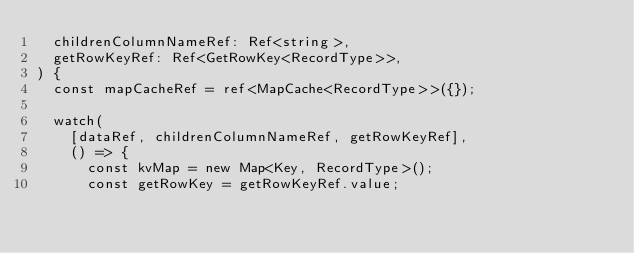Convert code to text. <code><loc_0><loc_0><loc_500><loc_500><_TypeScript_>  childrenColumnNameRef: Ref<string>,
  getRowKeyRef: Ref<GetRowKey<RecordType>>,
) {
  const mapCacheRef = ref<MapCache<RecordType>>({});

  watch(
    [dataRef, childrenColumnNameRef, getRowKeyRef],
    () => {
      const kvMap = new Map<Key, RecordType>();
      const getRowKey = getRowKeyRef.value;</code> 